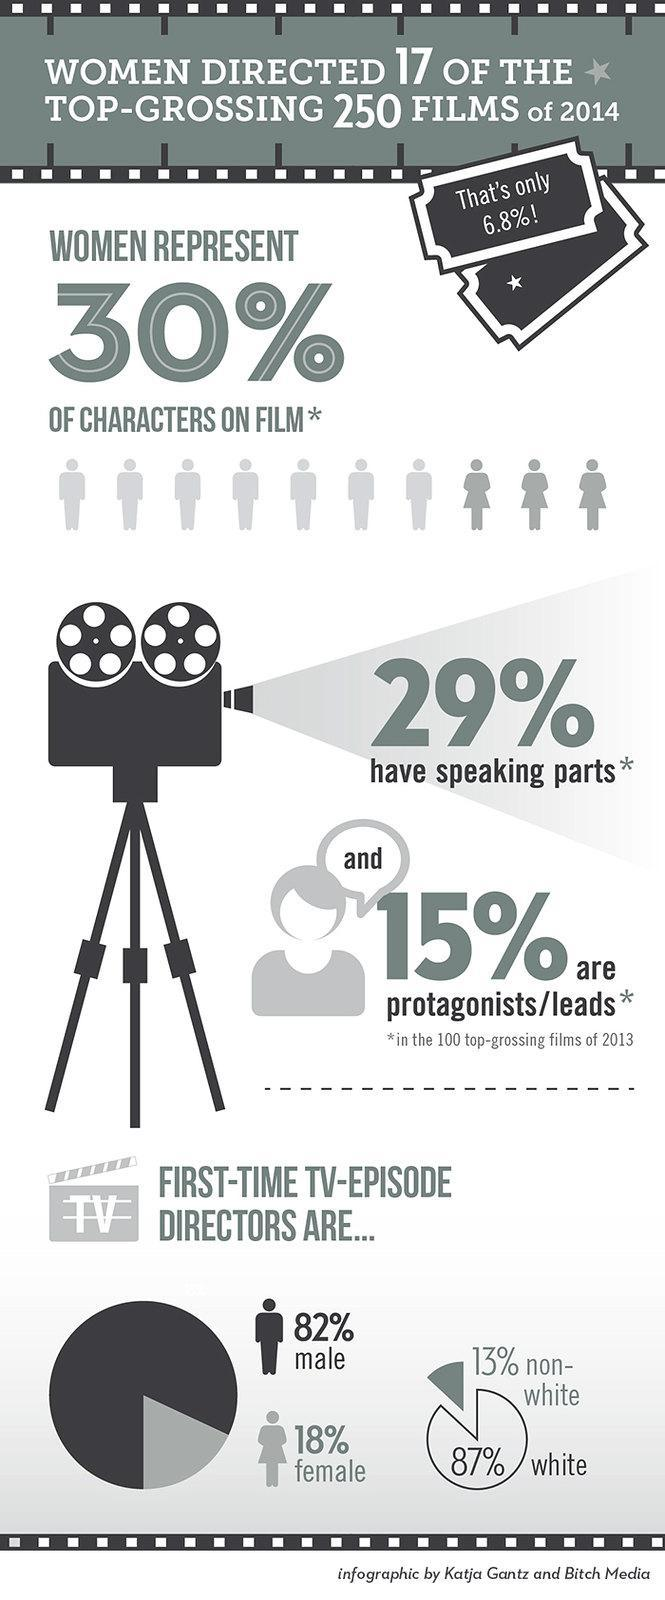What percentage of first-time TV-episode directors are non-whites in 2014?
Answer the question with a short phrase. 13% What percentage of women played lead roles in the 100 top-grossing films of 2013? 15% What percentage of women have speaking parts in the 100 top-grossing films of 2013? 29% What percentage of first-time TV-episode directors are males in 2014? 82% What percentage of first-time TV-episode directors are females in 2014? 18% 